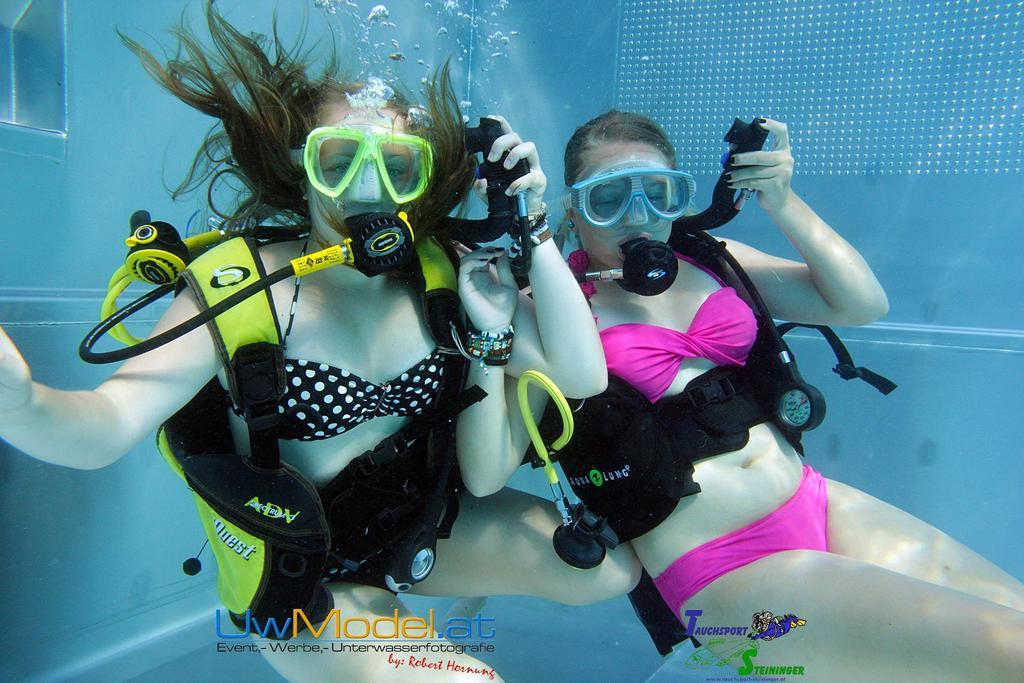How many people are in the image? There are two women in the image. Where are the women located in the image? The women are in the water. What equipment is visible in the image that might be used for underwater activities? There is underwater breathing equipment visible in the image. What type of addition problem can be solved using the numbers on the women's swimsuits in the image? There are no numbers visible on the women's swimsuits in the image, so it is not possible to solve an addition problem based on their swimsuits. 